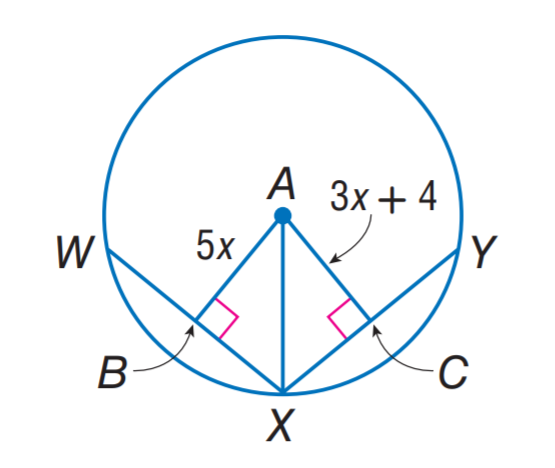Question: In \odot A, W X = X Y = 22. Find A B.
Choices:
A. 5
B. 10
C. 11
D. 22
Answer with the letter. Answer: B 